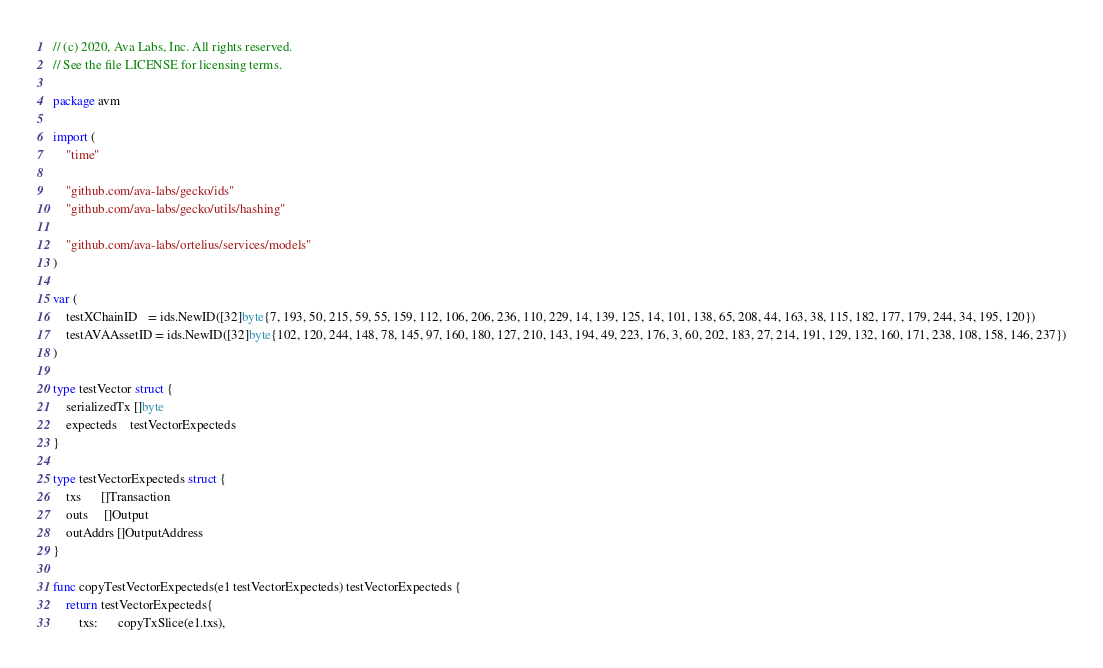Convert code to text. <code><loc_0><loc_0><loc_500><loc_500><_Go_>// (c) 2020, Ava Labs, Inc. All rights reserved.
// See the file LICENSE for licensing terms.

package avm

import (
	"time"

	"github.com/ava-labs/gecko/ids"
	"github.com/ava-labs/gecko/utils/hashing"

	"github.com/ava-labs/ortelius/services/models"
)

var (
	testXChainID   = ids.NewID([32]byte{7, 193, 50, 215, 59, 55, 159, 112, 106, 206, 236, 110, 229, 14, 139, 125, 14, 101, 138, 65, 208, 44, 163, 38, 115, 182, 177, 179, 244, 34, 195, 120})
	testAVAAssetID = ids.NewID([32]byte{102, 120, 244, 148, 78, 145, 97, 160, 180, 127, 210, 143, 194, 49, 223, 176, 3, 60, 202, 183, 27, 214, 191, 129, 132, 160, 171, 238, 108, 158, 146, 237})
)

type testVector struct {
	serializedTx []byte
	expecteds    testVectorExpecteds
}

type testVectorExpecteds struct {
	txs      []Transaction
	outs     []Output
	outAddrs []OutputAddress
}

func copyTestVectorExpecteds(e1 testVectorExpecteds) testVectorExpecteds {
	return testVectorExpecteds{
		txs:      copyTxSlice(e1.txs),</code> 